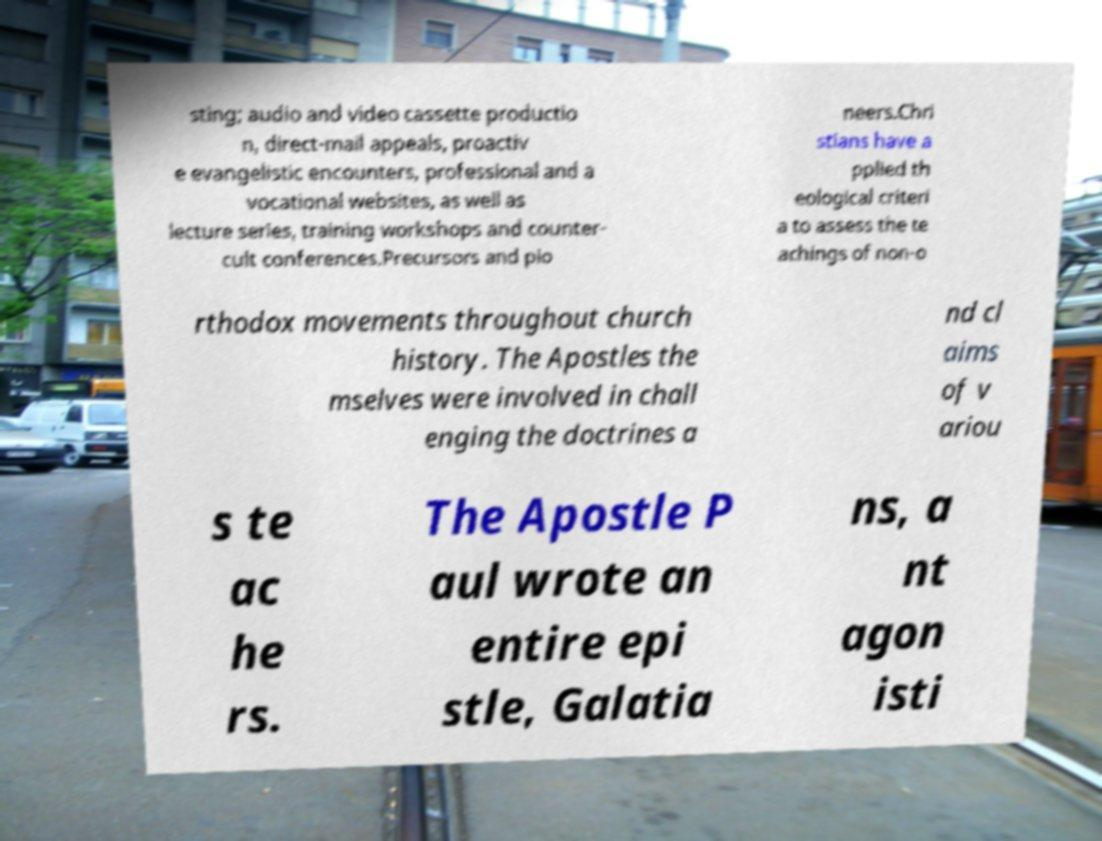Could you assist in decoding the text presented in this image and type it out clearly? sting; audio and video cassette productio n, direct-mail appeals, proactiv e evangelistic encounters, professional and a vocational websites, as well as lecture series, training workshops and counter- cult conferences.Precursors and pio neers.Chri stians have a pplied th eological criteri a to assess the te achings of non-o rthodox movements throughout church history. The Apostles the mselves were involved in chall enging the doctrines a nd cl aims of v ariou s te ac he rs. The Apostle P aul wrote an entire epi stle, Galatia ns, a nt agon isti 